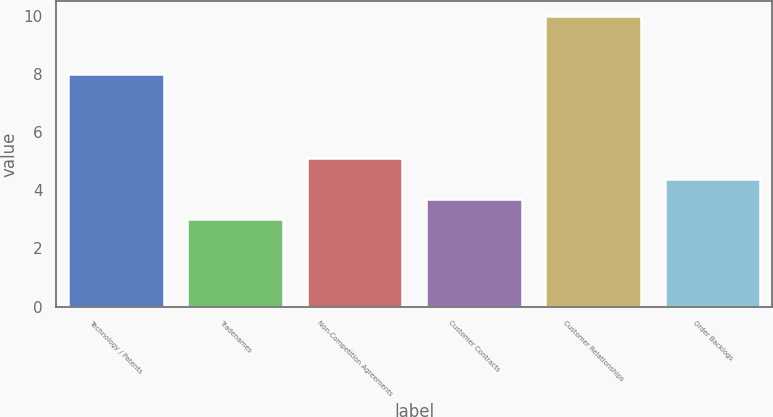<chart> <loc_0><loc_0><loc_500><loc_500><bar_chart><fcel>Technology / Patents<fcel>Tradenames<fcel>Non-Competition Agreements<fcel>Customer Contracts<fcel>Customer Relationships<fcel>Order Backlogs<nl><fcel>8<fcel>3<fcel>5.1<fcel>3.7<fcel>10<fcel>4.4<nl></chart> 